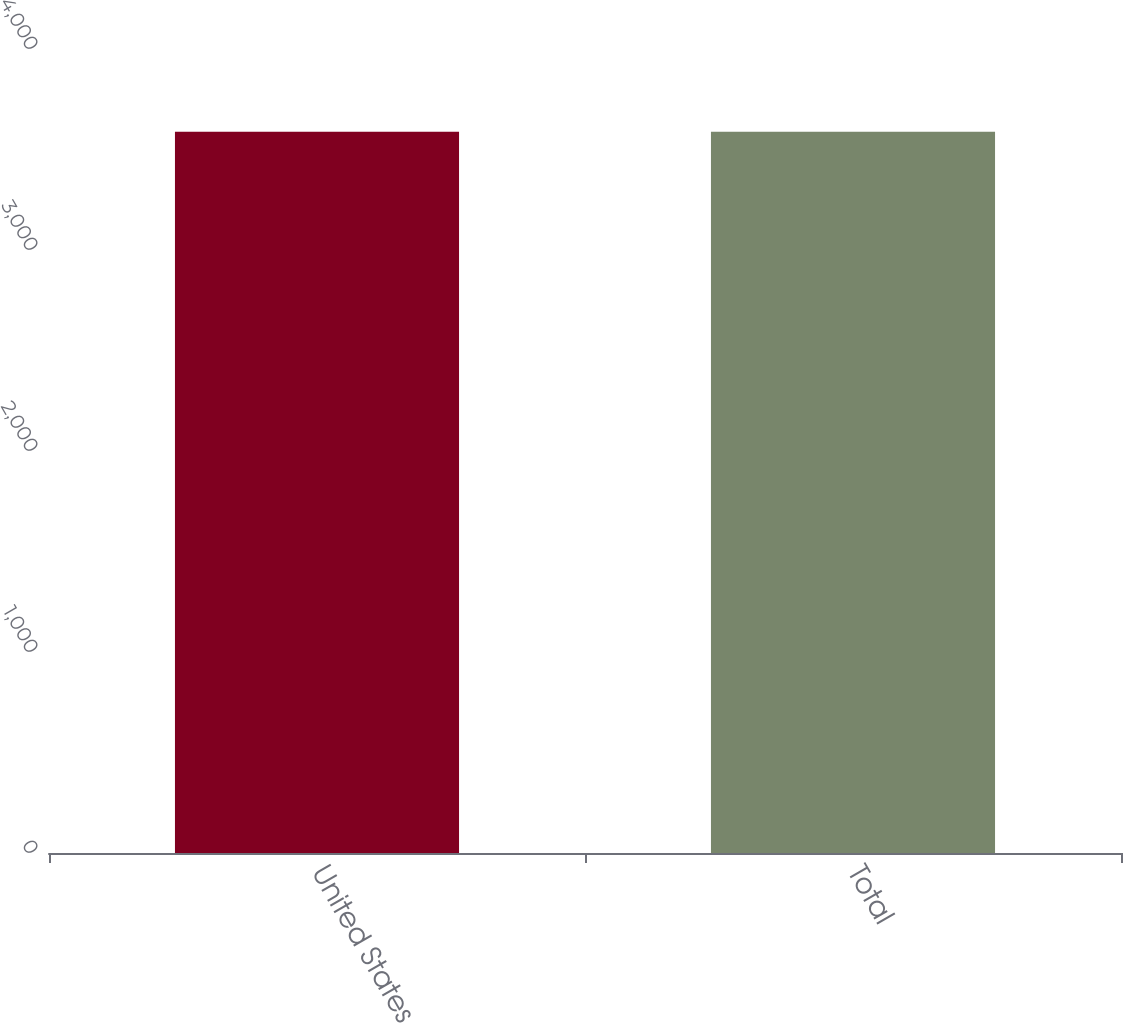<chart> <loc_0><loc_0><loc_500><loc_500><bar_chart><fcel>United States<fcel>Total<nl><fcel>3588<fcel>3588.1<nl></chart> 